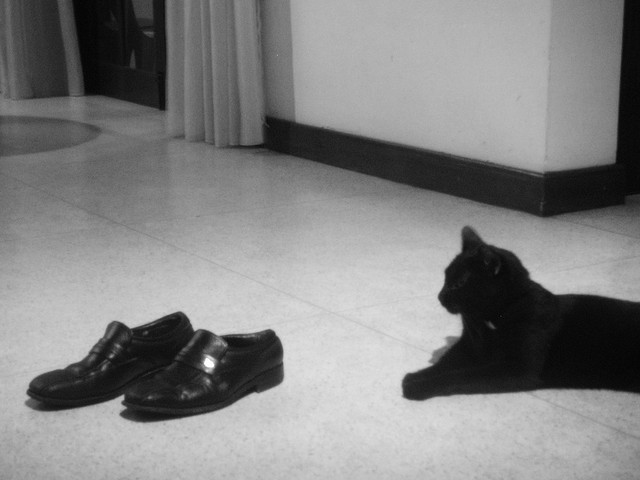<image>What brand of sneaker is the cat's foot on in the bottom picture? It is ambiguous as to which brand of sneaker the cat's foot is on in the bottom picture. It is not possible to determine the brand. What brand of sneaker is the cat's foot on in the bottom picture? I am not sure which brand of sneaker is the cat's foot on in the bottom picture. It is not possible to determine from the given information. 